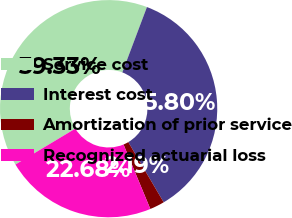<chart> <loc_0><loc_0><loc_500><loc_500><pie_chart><fcel>Service cost<fcel>Interest cost<fcel>Amortization of prior service<fcel>Recognized actuarial loss<nl><fcel>39.33%<fcel>35.8%<fcel>2.19%<fcel>22.68%<nl></chart> 